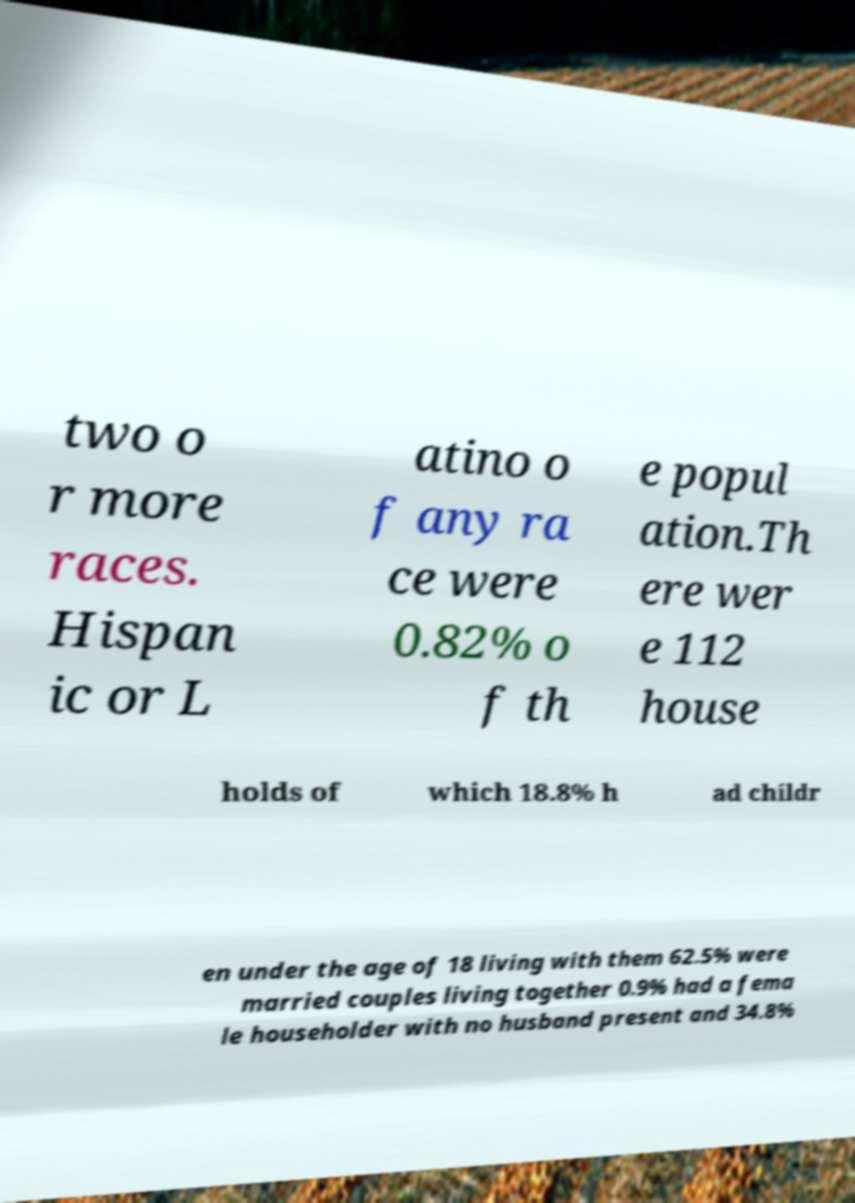Can you accurately transcribe the text from the provided image for me? two o r more races. Hispan ic or L atino o f any ra ce were 0.82% o f th e popul ation.Th ere wer e 112 house holds of which 18.8% h ad childr en under the age of 18 living with them 62.5% were married couples living together 0.9% had a fema le householder with no husband present and 34.8% 